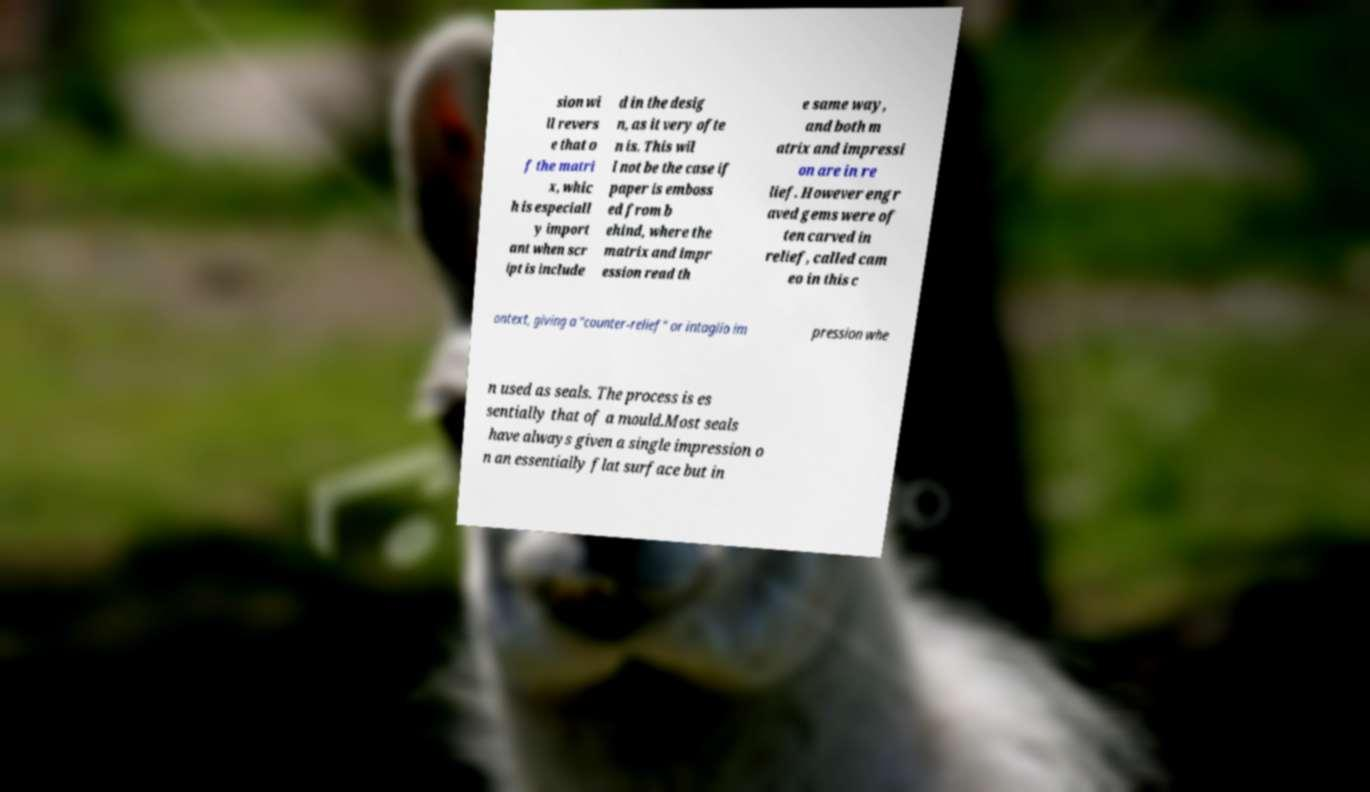Please identify and transcribe the text found in this image. sion wi ll revers e that o f the matri x, whic h is especiall y import ant when scr ipt is include d in the desig n, as it very ofte n is. This wil l not be the case if paper is emboss ed from b ehind, where the matrix and impr ession read th e same way, and both m atrix and impressi on are in re lief. However engr aved gems were of ten carved in relief, called cam eo in this c ontext, giving a "counter-relief" or intaglio im pression whe n used as seals. The process is es sentially that of a mould.Most seals have always given a single impression o n an essentially flat surface but in 